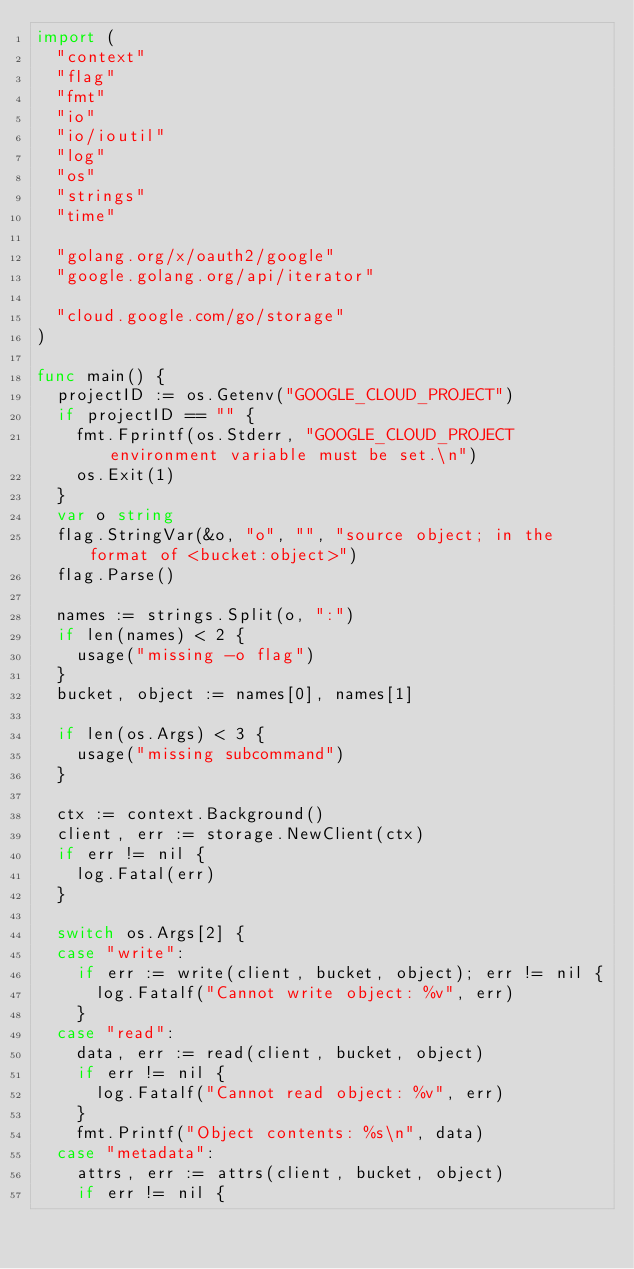Convert code to text. <code><loc_0><loc_0><loc_500><loc_500><_Go_>import (
	"context"
	"flag"
	"fmt"
	"io"
	"io/ioutil"
	"log"
	"os"
	"strings"
	"time"

	"golang.org/x/oauth2/google"
	"google.golang.org/api/iterator"

	"cloud.google.com/go/storage"
)

func main() {
	projectID := os.Getenv("GOOGLE_CLOUD_PROJECT")
	if projectID == "" {
		fmt.Fprintf(os.Stderr, "GOOGLE_CLOUD_PROJECT environment variable must be set.\n")
		os.Exit(1)
	}
	var o string
	flag.StringVar(&o, "o", "", "source object; in the format of <bucket:object>")
	flag.Parse()

	names := strings.Split(o, ":")
	if len(names) < 2 {
		usage("missing -o flag")
	}
	bucket, object := names[0], names[1]

	if len(os.Args) < 3 {
		usage("missing subcommand")
	}

	ctx := context.Background()
	client, err := storage.NewClient(ctx)
	if err != nil {
		log.Fatal(err)
	}

	switch os.Args[2] {
	case "write":
		if err := write(client, bucket, object); err != nil {
			log.Fatalf("Cannot write object: %v", err)
		}
	case "read":
		data, err := read(client, bucket, object)
		if err != nil {
			log.Fatalf("Cannot read object: %v", err)
		}
		fmt.Printf("Object contents: %s\n", data)
	case "metadata":
		attrs, err := attrs(client, bucket, object)
		if err != nil {</code> 